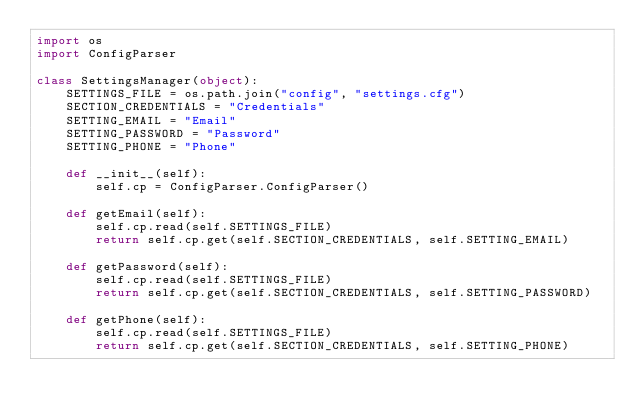Convert code to text. <code><loc_0><loc_0><loc_500><loc_500><_Python_>import os
import ConfigParser

class SettingsManager(object):
    SETTINGS_FILE = os.path.join("config", "settings.cfg")
    SECTION_CREDENTIALS = "Credentials"
    SETTING_EMAIL = "Email"
    SETTING_PASSWORD = "Password"
    SETTING_PHONE = "Phone"

    def __init__(self):
        self.cp = ConfigParser.ConfigParser()

    def getEmail(self):
        self.cp.read(self.SETTINGS_FILE)
        return self.cp.get(self.SECTION_CREDENTIALS, self.SETTING_EMAIL)

    def getPassword(self):
        self.cp.read(self.SETTINGS_FILE)
        return self.cp.get(self.SECTION_CREDENTIALS, self.SETTING_PASSWORD)

    def getPhone(self):
        self.cp.read(self.SETTINGS_FILE)
        return self.cp.get(self.SECTION_CREDENTIALS, self.SETTING_PHONE)
</code> 